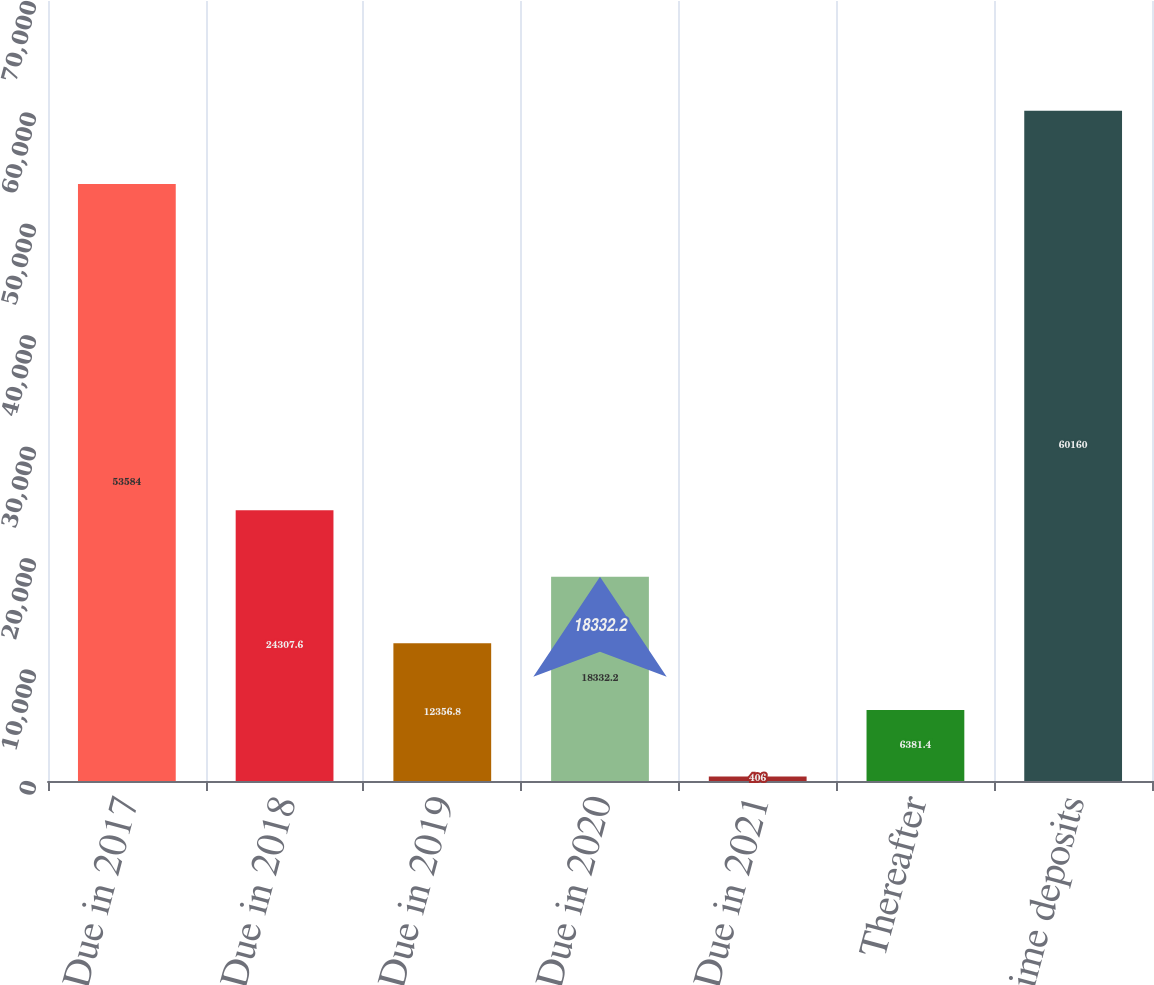<chart> <loc_0><loc_0><loc_500><loc_500><bar_chart><fcel>Due in 2017<fcel>Due in 2018<fcel>Due in 2019<fcel>Due in 2020<fcel>Due in 2021<fcel>Thereafter<fcel>Total time deposits<nl><fcel>53584<fcel>24307.6<fcel>12356.8<fcel>18332.2<fcel>406<fcel>6381.4<fcel>60160<nl></chart> 